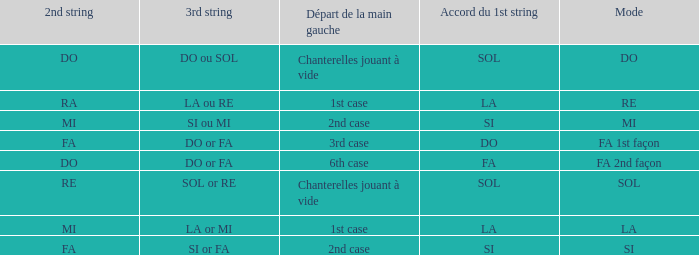For the 2nd string of Do and an Accord du 1st string of FA what is the Depart de la main gauche? 6th case. 